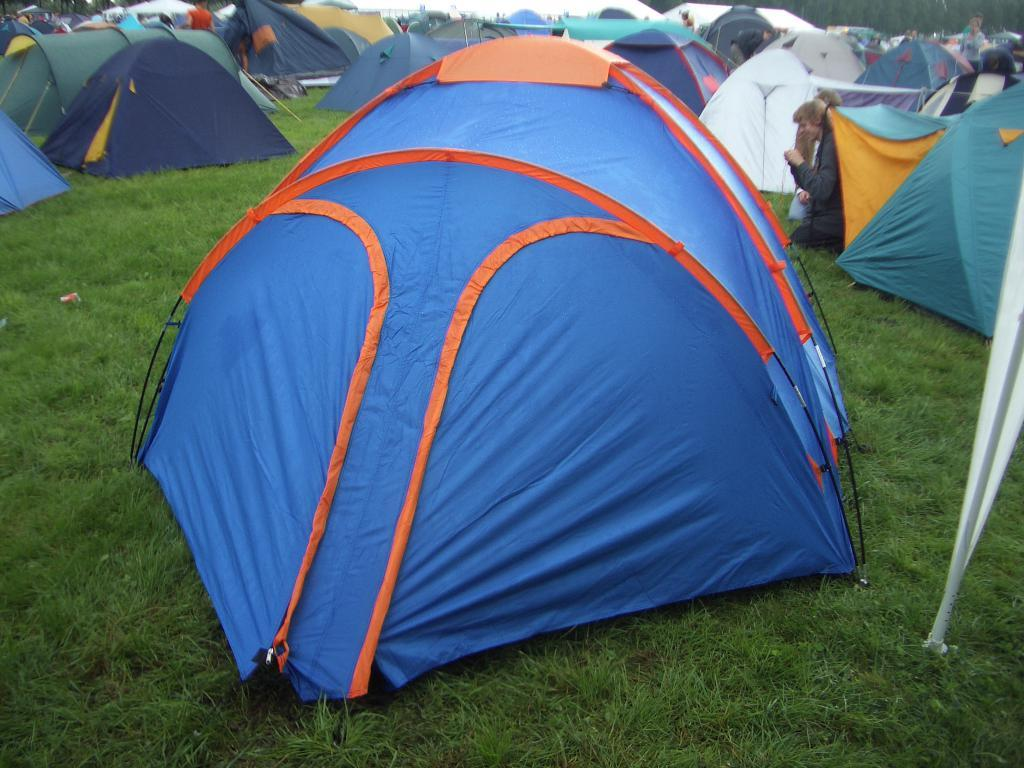What type of structures can be seen in the image? There are tents with different colors in the image. What are the two people in the image doing? They are sitting on their knees in the image. What is the ground made of in the image? There is green grass in the image. How many cups can be seen on the grass in the image? There are no cups present in the image; it features tents and people sitting on their knees. What type of creature is shown interacting with the grass in the image? There is no creature shown interacting with the grass in the image; only the tents and people are present. 